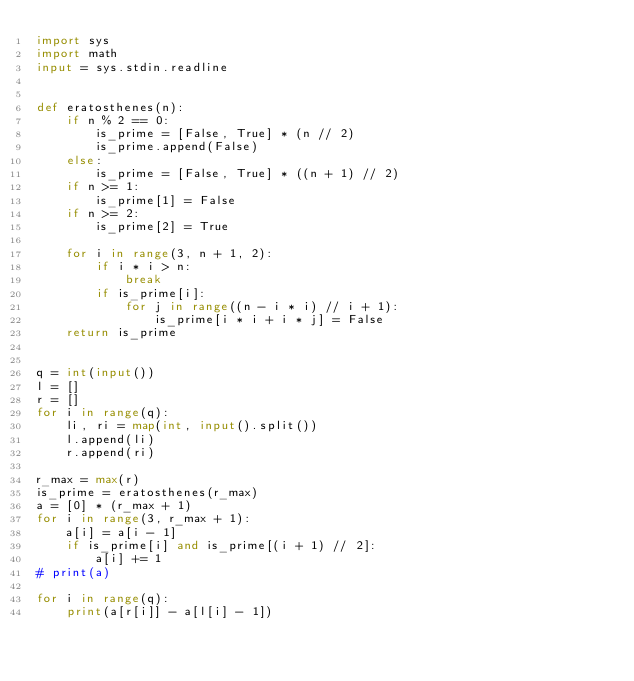<code> <loc_0><loc_0><loc_500><loc_500><_Python_>import sys
import math
input = sys.stdin.readline


def eratosthenes(n):
    if n % 2 == 0:
        is_prime = [False, True] * (n // 2)
        is_prime.append(False)
    else:
        is_prime = [False, True] * ((n + 1) // 2)
    if n >= 1:
        is_prime[1] = False
    if n >= 2:
        is_prime[2] = True

    for i in range(3, n + 1, 2):
        if i * i > n:
            break
        if is_prime[i]:
            for j in range((n - i * i) // i + 1):
                is_prime[i * i + i * j] = False
    return is_prime


q = int(input())
l = []
r = []
for i in range(q):
    li, ri = map(int, input().split())
    l.append(li)
    r.append(ri)

r_max = max(r)
is_prime = eratosthenes(r_max)
a = [0] * (r_max + 1)
for i in range(3, r_max + 1):
    a[i] = a[i - 1]
    if is_prime[i] and is_prime[(i + 1) // 2]:
        a[i] += 1
# print(a)

for i in range(q):
    print(a[r[i]] - a[l[i] - 1])
</code> 